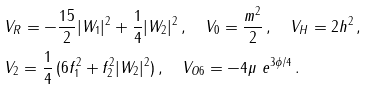<formula> <loc_0><loc_0><loc_500><loc_500>& V _ { R } = - \frac { 1 5 } { 2 } | W _ { 1 } | ^ { 2 } + \frac { 1 } { 4 } | W _ { 2 } | ^ { 2 } \, , \quad V _ { 0 } = \frac { m ^ { 2 } } { 2 } \, , \quad V _ { H } = 2 h ^ { 2 } \, , \\ & V _ { 2 } = \frac { 1 } { 4 } \, ( 6 f _ { 1 } ^ { 2 } + f _ { 2 } ^ { 2 } | W _ { 2 } | ^ { 2 } ) \, , \quad V _ { O 6 } = - 4 \mu \ e ^ { 3 \phi / 4 } \, .</formula> 